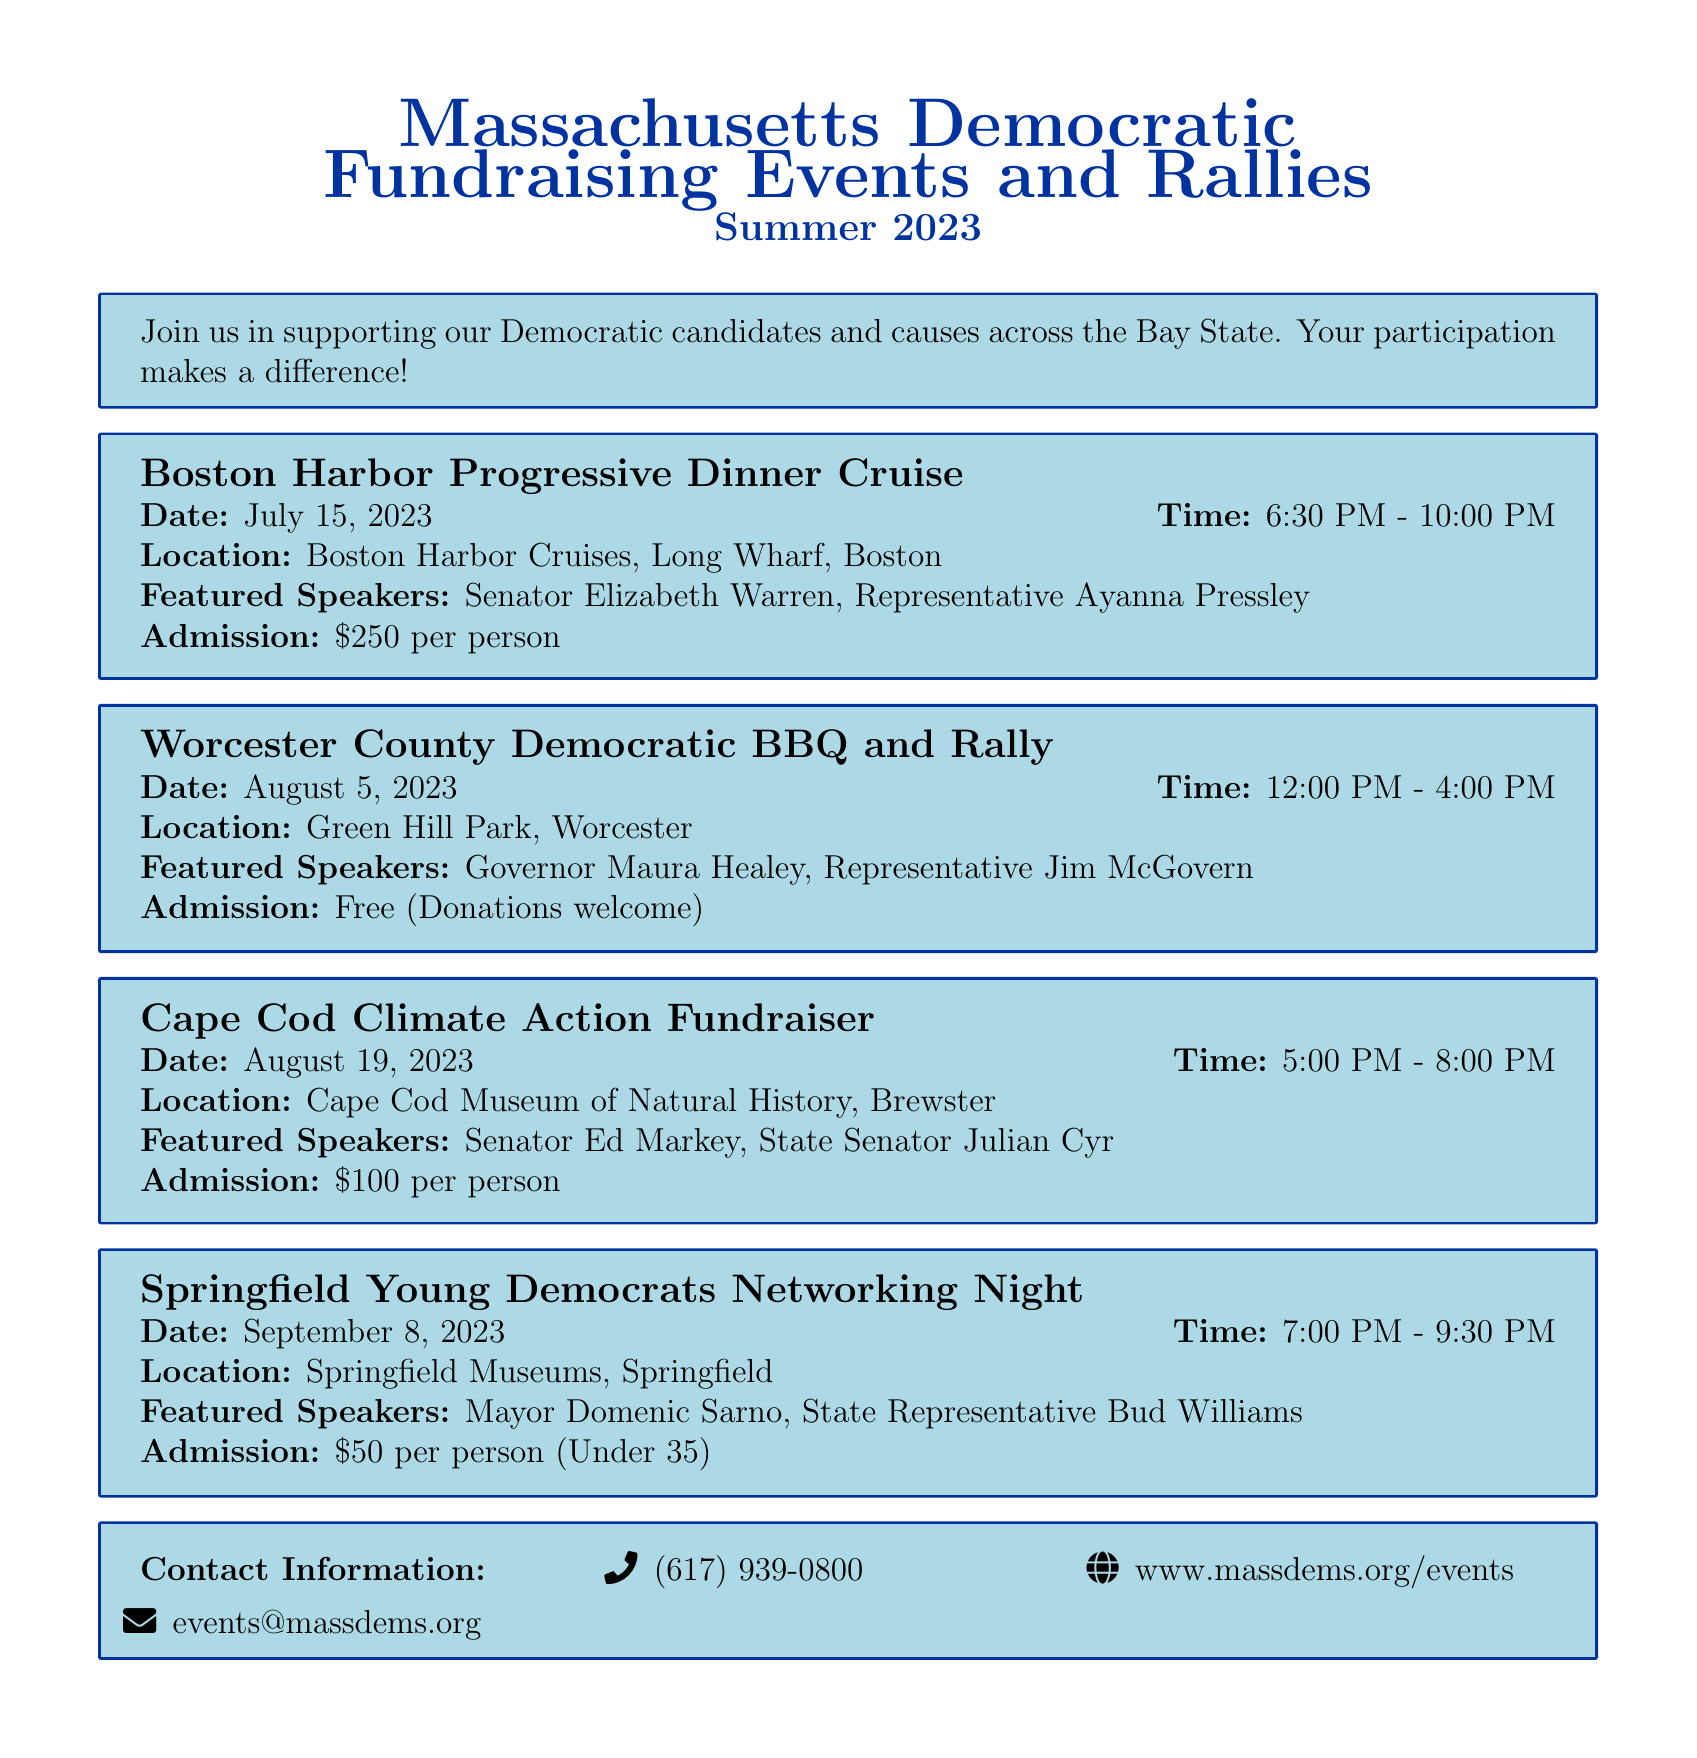What is the date of the Boston Harbor Progressive Dinner Cruise? The date is listed in the document under the event's title.
Answer: July 15, 2023 Who are the featured speakers at the Worcester County Democratic BBQ and Rally? The speakers are mentioned in the event's details.
Answer: Governor Maura Healey, Representative Jim McGovern What is the admission fee for the Cape Cod Climate Action Fundraiser? The admission fee is clearly noted in the event's description.
Answer: $100 per person What is the location for the Springfield Young Democrats Networking Night? The location is provided for the event in the document.
Answer: Springfield Museums, Springfield How long is the Boston Harbor Progressive Dinner Cruise scheduled to last? The time information is available under the event details, and the duration is calculated from the start and end times.
Answer: 3 hours and 30 minutes What type of event is scheduled on August 5, 2023? The document specifies the nature of events under the event titles.
Answer: BBQ and Rally What contact method is listed for events in the document? Contact methods are provided in the contact information section.
Answer: events@massdems.org How many featured speakers are listed for the Cape Cod Climate Action Fundraiser? The number of speakers can be identified from the event details.
Answer: 2 